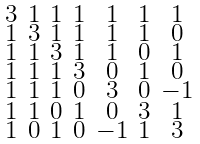<formula> <loc_0><loc_0><loc_500><loc_500>\begin{smallmatrix} 3 & 1 & 1 & 1 & 1 & 1 & 1 \\ 1 & 3 & 1 & 1 & 1 & 1 & 0 \\ 1 & 1 & 3 & 1 & 1 & 0 & 1 \\ 1 & 1 & 1 & 3 & 0 & 1 & 0 \\ 1 & 1 & 1 & 0 & 3 & 0 & - 1 \\ 1 & 1 & 0 & 1 & 0 & 3 & 1 \\ 1 & 0 & 1 & 0 & - 1 & 1 & 3 \end{smallmatrix}</formula> 